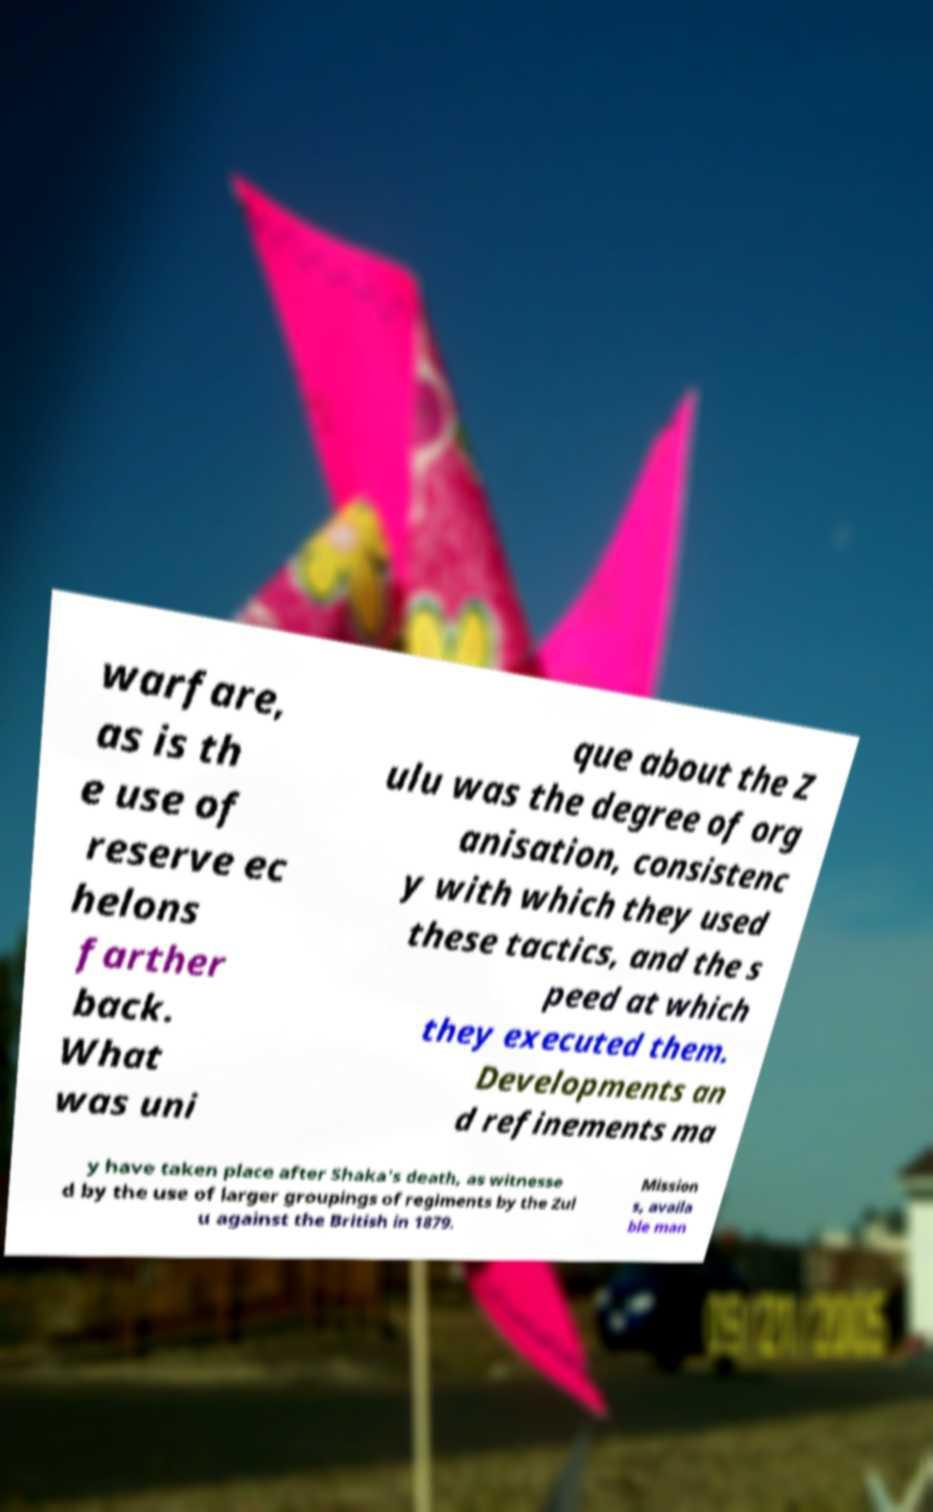Please read and relay the text visible in this image. What does it say? warfare, as is th e use of reserve ec helons farther back. What was uni que about the Z ulu was the degree of org anisation, consistenc y with which they used these tactics, and the s peed at which they executed them. Developments an d refinements ma y have taken place after Shaka's death, as witnesse d by the use of larger groupings of regiments by the Zul u against the British in 1879. Mission s, availa ble man 